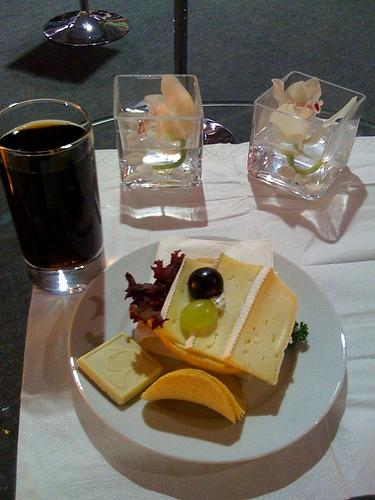What kind of chips are served on the plate? Please explain your reasoning. pringles. The chips are in the shape of pringles. 